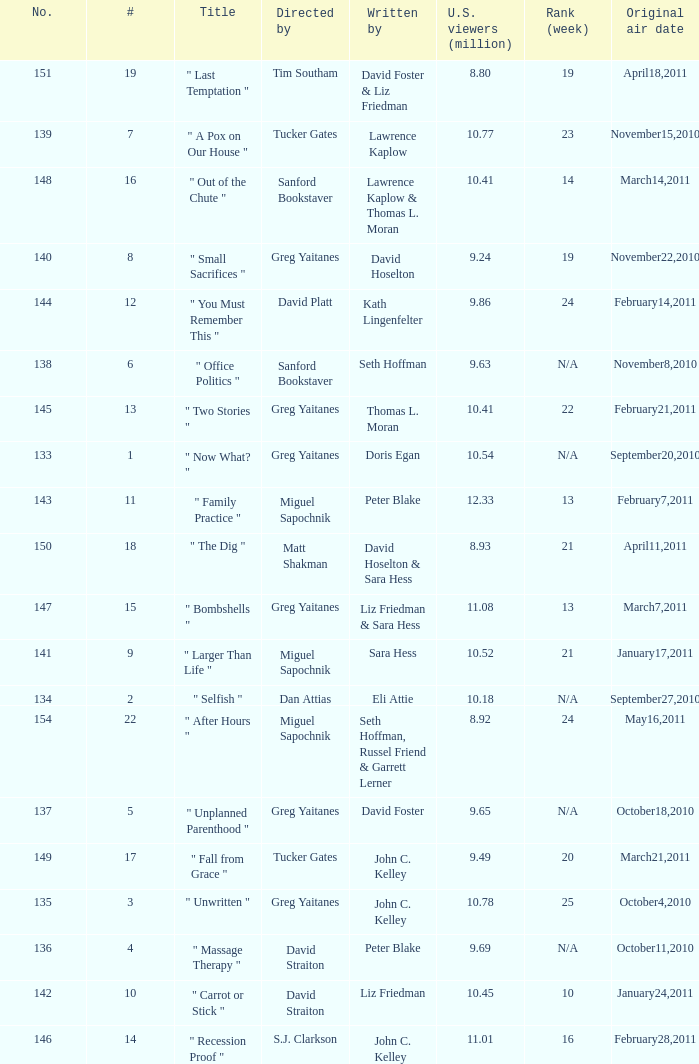Where did the episode rank that was written by thomas l. moran? 22.0. 